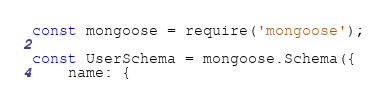Convert code to text. <code><loc_0><loc_0><loc_500><loc_500><_JavaScript_>const mongoose = require('mongoose');

const UserSchema = mongoose.Schema({
	name: {</code> 